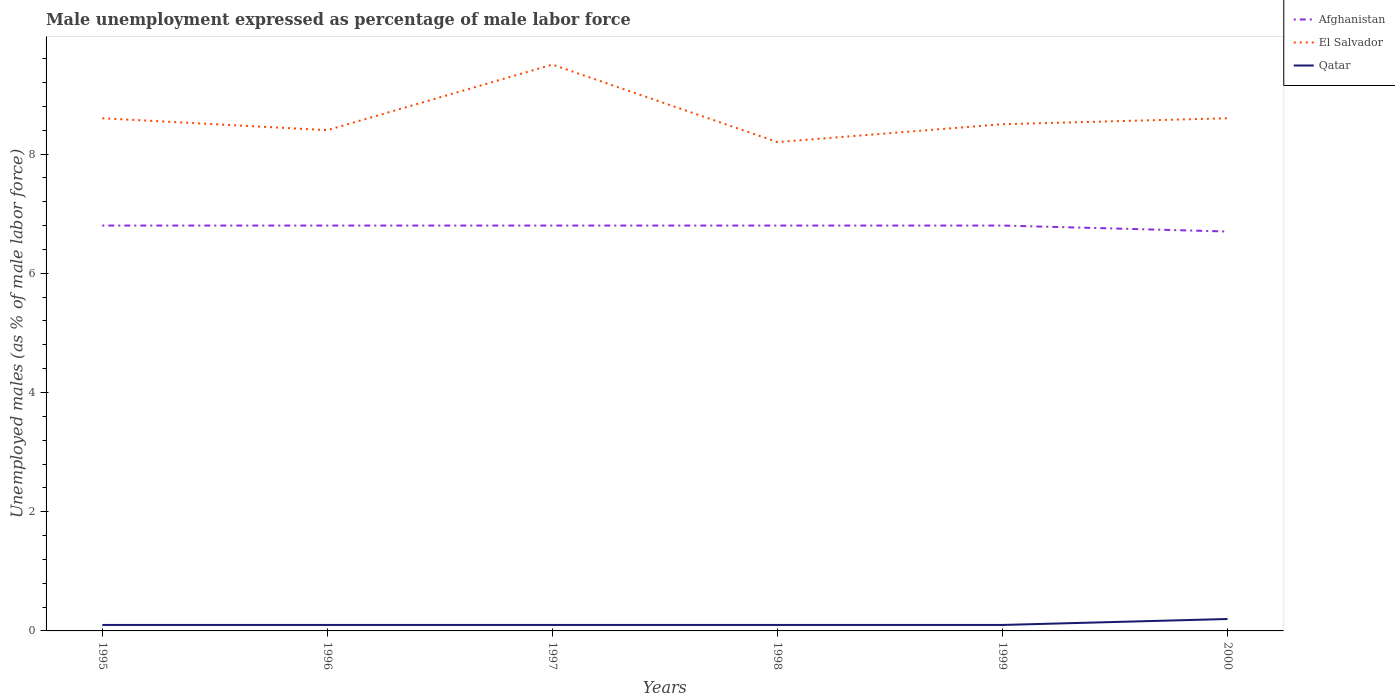How many different coloured lines are there?
Provide a short and direct response. 3. Across all years, what is the maximum unemployment in males in in El Salvador?
Offer a terse response. 8.2. In which year was the unemployment in males in in El Salvador maximum?
Keep it short and to the point. 1998. What is the total unemployment in males in in Qatar in the graph?
Your answer should be compact. -0.1. What is the difference between the highest and the second highest unemployment in males in in Afghanistan?
Your answer should be compact. 0.1. What is the difference between the highest and the lowest unemployment in males in in Qatar?
Your response must be concise. 1. How many lines are there?
Give a very brief answer. 3. Does the graph contain any zero values?
Provide a succinct answer. No. Where does the legend appear in the graph?
Give a very brief answer. Top right. How are the legend labels stacked?
Provide a succinct answer. Vertical. What is the title of the graph?
Ensure brevity in your answer.  Male unemployment expressed as percentage of male labor force. What is the label or title of the X-axis?
Provide a short and direct response. Years. What is the label or title of the Y-axis?
Your response must be concise. Unemployed males (as % of male labor force). What is the Unemployed males (as % of male labor force) of Afghanistan in 1995?
Your answer should be compact. 6.8. What is the Unemployed males (as % of male labor force) in El Salvador in 1995?
Offer a terse response. 8.6. What is the Unemployed males (as % of male labor force) in Qatar in 1995?
Ensure brevity in your answer.  0.1. What is the Unemployed males (as % of male labor force) of Afghanistan in 1996?
Your answer should be compact. 6.8. What is the Unemployed males (as % of male labor force) in El Salvador in 1996?
Offer a very short reply. 8.4. What is the Unemployed males (as % of male labor force) in Qatar in 1996?
Make the answer very short. 0.1. What is the Unemployed males (as % of male labor force) of Afghanistan in 1997?
Provide a succinct answer. 6.8. What is the Unemployed males (as % of male labor force) in Qatar in 1997?
Make the answer very short. 0.1. What is the Unemployed males (as % of male labor force) of Afghanistan in 1998?
Offer a terse response. 6.8. What is the Unemployed males (as % of male labor force) of El Salvador in 1998?
Ensure brevity in your answer.  8.2. What is the Unemployed males (as % of male labor force) of Qatar in 1998?
Your response must be concise. 0.1. What is the Unemployed males (as % of male labor force) in Afghanistan in 1999?
Offer a very short reply. 6.8. What is the Unemployed males (as % of male labor force) in Qatar in 1999?
Provide a succinct answer. 0.1. What is the Unemployed males (as % of male labor force) of Afghanistan in 2000?
Provide a short and direct response. 6.7. What is the Unemployed males (as % of male labor force) of El Salvador in 2000?
Provide a succinct answer. 8.6. What is the Unemployed males (as % of male labor force) of Qatar in 2000?
Your answer should be compact. 0.2. Across all years, what is the maximum Unemployed males (as % of male labor force) in Afghanistan?
Offer a very short reply. 6.8. Across all years, what is the maximum Unemployed males (as % of male labor force) of Qatar?
Ensure brevity in your answer.  0.2. Across all years, what is the minimum Unemployed males (as % of male labor force) in Afghanistan?
Offer a very short reply. 6.7. Across all years, what is the minimum Unemployed males (as % of male labor force) in El Salvador?
Provide a short and direct response. 8.2. Across all years, what is the minimum Unemployed males (as % of male labor force) in Qatar?
Your answer should be compact. 0.1. What is the total Unemployed males (as % of male labor force) of Afghanistan in the graph?
Your answer should be compact. 40.7. What is the total Unemployed males (as % of male labor force) of El Salvador in the graph?
Your answer should be very brief. 51.8. What is the difference between the Unemployed males (as % of male labor force) of Afghanistan in 1995 and that in 1996?
Offer a terse response. 0. What is the difference between the Unemployed males (as % of male labor force) in Qatar in 1995 and that in 1996?
Your response must be concise. 0. What is the difference between the Unemployed males (as % of male labor force) of Afghanistan in 1995 and that in 1997?
Your response must be concise. 0. What is the difference between the Unemployed males (as % of male labor force) in Qatar in 1995 and that in 1997?
Keep it short and to the point. 0. What is the difference between the Unemployed males (as % of male labor force) of Afghanistan in 1995 and that in 1998?
Offer a very short reply. 0. What is the difference between the Unemployed males (as % of male labor force) of Qatar in 1995 and that in 1998?
Give a very brief answer. 0. What is the difference between the Unemployed males (as % of male labor force) of Afghanistan in 1995 and that in 1999?
Offer a terse response. 0. What is the difference between the Unemployed males (as % of male labor force) in El Salvador in 1995 and that in 2000?
Provide a short and direct response. 0. What is the difference between the Unemployed males (as % of male labor force) in Qatar in 1995 and that in 2000?
Keep it short and to the point. -0.1. What is the difference between the Unemployed males (as % of male labor force) in El Salvador in 1996 and that in 1997?
Provide a short and direct response. -1.1. What is the difference between the Unemployed males (as % of male labor force) in Qatar in 1996 and that in 1998?
Your response must be concise. 0. What is the difference between the Unemployed males (as % of male labor force) in Afghanistan in 1996 and that in 1999?
Your answer should be very brief. 0. What is the difference between the Unemployed males (as % of male labor force) of Qatar in 1996 and that in 1999?
Ensure brevity in your answer.  0. What is the difference between the Unemployed males (as % of male labor force) in El Salvador in 1996 and that in 2000?
Offer a very short reply. -0.2. What is the difference between the Unemployed males (as % of male labor force) in Qatar in 1997 and that in 1998?
Ensure brevity in your answer.  0. What is the difference between the Unemployed males (as % of male labor force) of El Salvador in 1997 and that in 1999?
Offer a very short reply. 1. What is the difference between the Unemployed males (as % of male labor force) of Qatar in 1997 and that in 1999?
Keep it short and to the point. 0. What is the difference between the Unemployed males (as % of male labor force) in Afghanistan in 1997 and that in 2000?
Offer a very short reply. 0.1. What is the difference between the Unemployed males (as % of male labor force) of Qatar in 1998 and that in 1999?
Offer a very short reply. 0. What is the difference between the Unemployed males (as % of male labor force) of El Salvador in 1998 and that in 2000?
Offer a terse response. -0.4. What is the difference between the Unemployed males (as % of male labor force) of Qatar in 1998 and that in 2000?
Provide a succinct answer. -0.1. What is the difference between the Unemployed males (as % of male labor force) in Afghanistan in 1999 and that in 2000?
Your response must be concise. 0.1. What is the difference between the Unemployed males (as % of male labor force) in Afghanistan in 1995 and the Unemployed males (as % of male labor force) in El Salvador in 1996?
Keep it short and to the point. -1.6. What is the difference between the Unemployed males (as % of male labor force) in Afghanistan in 1995 and the Unemployed males (as % of male labor force) in Qatar in 1997?
Make the answer very short. 6.7. What is the difference between the Unemployed males (as % of male labor force) of El Salvador in 1995 and the Unemployed males (as % of male labor force) of Qatar in 1997?
Provide a succinct answer. 8.5. What is the difference between the Unemployed males (as % of male labor force) in Afghanistan in 1995 and the Unemployed males (as % of male labor force) in El Salvador in 1998?
Make the answer very short. -1.4. What is the difference between the Unemployed males (as % of male labor force) in Afghanistan in 1995 and the Unemployed males (as % of male labor force) in Qatar in 1999?
Your answer should be very brief. 6.7. What is the difference between the Unemployed males (as % of male labor force) in Afghanistan in 1995 and the Unemployed males (as % of male labor force) in El Salvador in 2000?
Your answer should be compact. -1.8. What is the difference between the Unemployed males (as % of male labor force) of Afghanistan in 1995 and the Unemployed males (as % of male labor force) of Qatar in 2000?
Offer a very short reply. 6.6. What is the difference between the Unemployed males (as % of male labor force) of El Salvador in 1995 and the Unemployed males (as % of male labor force) of Qatar in 2000?
Ensure brevity in your answer.  8.4. What is the difference between the Unemployed males (as % of male labor force) of Afghanistan in 1996 and the Unemployed males (as % of male labor force) of El Salvador in 1997?
Your answer should be compact. -2.7. What is the difference between the Unemployed males (as % of male labor force) of El Salvador in 1996 and the Unemployed males (as % of male labor force) of Qatar in 1997?
Offer a very short reply. 8.3. What is the difference between the Unemployed males (as % of male labor force) in Afghanistan in 1996 and the Unemployed males (as % of male labor force) in El Salvador in 1998?
Provide a succinct answer. -1.4. What is the difference between the Unemployed males (as % of male labor force) in Afghanistan in 1996 and the Unemployed males (as % of male labor force) in Qatar in 1998?
Your answer should be compact. 6.7. What is the difference between the Unemployed males (as % of male labor force) in Afghanistan in 1996 and the Unemployed males (as % of male labor force) in El Salvador in 2000?
Your answer should be compact. -1.8. What is the difference between the Unemployed males (as % of male labor force) in Afghanistan in 1996 and the Unemployed males (as % of male labor force) in Qatar in 2000?
Your answer should be compact. 6.6. What is the difference between the Unemployed males (as % of male labor force) of Afghanistan in 1997 and the Unemployed males (as % of male labor force) of El Salvador in 1998?
Your response must be concise. -1.4. What is the difference between the Unemployed males (as % of male labor force) in Afghanistan in 1997 and the Unemployed males (as % of male labor force) in Qatar in 1998?
Your response must be concise. 6.7. What is the difference between the Unemployed males (as % of male labor force) in El Salvador in 1997 and the Unemployed males (as % of male labor force) in Qatar in 1998?
Ensure brevity in your answer.  9.4. What is the difference between the Unemployed males (as % of male labor force) of Afghanistan in 1997 and the Unemployed males (as % of male labor force) of El Salvador in 1999?
Give a very brief answer. -1.7. What is the difference between the Unemployed males (as % of male labor force) in Afghanistan in 1997 and the Unemployed males (as % of male labor force) in Qatar in 1999?
Your answer should be compact. 6.7. What is the difference between the Unemployed males (as % of male labor force) in El Salvador in 1997 and the Unemployed males (as % of male labor force) in Qatar in 1999?
Ensure brevity in your answer.  9.4. What is the difference between the Unemployed males (as % of male labor force) of Afghanistan in 1997 and the Unemployed males (as % of male labor force) of Qatar in 2000?
Offer a very short reply. 6.6. What is the difference between the Unemployed males (as % of male labor force) in El Salvador in 1997 and the Unemployed males (as % of male labor force) in Qatar in 2000?
Provide a succinct answer. 9.3. What is the difference between the Unemployed males (as % of male labor force) in Afghanistan in 1998 and the Unemployed males (as % of male labor force) in Qatar in 1999?
Your answer should be very brief. 6.7. What is the difference between the Unemployed males (as % of male labor force) of El Salvador in 1998 and the Unemployed males (as % of male labor force) of Qatar in 1999?
Give a very brief answer. 8.1. What is the difference between the Unemployed males (as % of male labor force) in El Salvador in 1999 and the Unemployed males (as % of male labor force) in Qatar in 2000?
Your answer should be very brief. 8.3. What is the average Unemployed males (as % of male labor force) of Afghanistan per year?
Offer a very short reply. 6.78. What is the average Unemployed males (as % of male labor force) of El Salvador per year?
Your answer should be compact. 8.63. What is the average Unemployed males (as % of male labor force) of Qatar per year?
Ensure brevity in your answer.  0.12. In the year 1997, what is the difference between the Unemployed males (as % of male labor force) of Afghanistan and Unemployed males (as % of male labor force) of El Salvador?
Your response must be concise. -2.7. In the year 1999, what is the difference between the Unemployed males (as % of male labor force) in Afghanistan and Unemployed males (as % of male labor force) in El Salvador?
Provide a succinct answer. -1.7. In the year 1999, what is the difference between the Unemployed males (as % of male labor force) in Afghanistan and Unemployed males (as % of male labor force) in Qatar?
Offer a terse response. 6.7. What is the ratio of the Unemployed males (as % of male labor force) of Afghanistan in 1995 to that in 1996?
Provide a succinct answer. 1. What is the ratio of the Unemployed males (as % of male labor force) in El Salvador in 1995 to that in 1996?
Offer a terse response. 1.02. What is the ratio of the Unemployed males (as % of male labor force) in Qatar in 1995 to that in 1996?
Your answer should be compact. 1. What is the ratio of the Unemployed males (as % of male labor force) of El Salvador in 1995 to that in 1997?
Keep it short and to the point. 0.91. What is the ratio of the Unemployed males (as % of male labor force) of El Salvador in 1995 to that in 1998?
Keep it short and to the point. 1.05. What is the ratio of the Unemployed males (as % of male labor force) in Qatar in 1995 to that in 1998?
Make the answer very short. 1. What is the ratio of the Unemployed males (as % of male labor force) of Afghanistan in 1995 to that in 1999?
Keep it short and to the point. 1. What is the ratio of the Unemployed males (as % of male labor force) of El Salvador in 1995 to that in 1999?
Offer a very short reply. 1.01. What is the ratio of the Unemployed males (as % of male labor force) in Qatar in 1995 to that in 1999?
Offer a very short reply. 1. What is the ratio of the Unemployed males (as % of male labor force) of Afghanistan in 1995 to that in 2000?
Your response must be concise. 1.01. What is the ratio of the Unemployed males (as % of male labor force) of Afghanistan in 1996 to that in 1997?
Keep it short and to the point. 1. What is the ratio of the Unemployed males (as % of male labor force) in El Salvador in 1996 to that in 1997?
Give a very brief answer. 0.88. What is the ratio of the Unemployed males (as % of male labor force) of Qatar in 1996 to that in 1997?
Provide a succinct answer. 1. What is the ratio of the Unemployed males (as % of male labor force) of Afghanistan in 1996 to that in 1998?
Ensure brevity in your answer.  1. What is the ratio of the Unemployed males (as % of male labor force) in El Salvador in 1996 to that in 1998?
Keep it short and to the point. 1.02. What is the ratio of the Unemployed males (as % of male labor force) of Qatar in 1996 to that in 1998?
Provide a short and direct response. 1. What is the ratio of the Unemployed males (as % of male labor force) in Afghanistan in 1996 to that in 1999?
Offer a terse response. 1. What is the ratio of the Unemployed males (as % of male labor force) in El Salvador in 1996 to that in 1999?
Provide a succinct answer. 0.99. What is the ratio of the Unemployed males (as % of male labor force) in Qatar in 1996 to that in 1999?
Offer a very short reply. 1. What is the ratio of the Unemployed males (as % of male labor force) of Afghanistan in 1996 to that in 2000?
Provide a succinct answer. 1.01. What is the ratio of the Unemployed males (as % of male labor force) in El Salvador in 1996 to that in 2000?
Ensure brevity in your answer.  0.98. What is the ratio of the Unemployed males (as % of male labor force) in Afghanistan in 1997 to that in 1998?
Give a very brief answer. 1. What is the ratio of the Unemployed males (as % of male labor force) in El Salvador in 1997 to that in 1998?
Your answer should be very brief. 1.16. What is the ratio of the Unemployed males (as % of male labor force) in Afghanistan in 1997 to that in 1999?
Give a very brief answer. 1. What is the ratio of the Unemployed males (as % of male labor force) of El Salvador in 1997 to that in 1999?
Ensure brevity in your answer.  1.12. What is the ratio of the Unemployed males (as % of male labor force) in Afghanistan in 1997 to that in 2000?
Your response must be concise. 1.01. What is the ratio of the Unemployed males (as % of male labor force) of El Salvador in 1997 to that in 2000?
Keep it short and to the point. 1.1. What is the ratio of the Unemployed males (as % of male labor force) in Qatar in 1997 to that in 2000?
Provide a short and direct response. 0.5. What is the ratio of the Unemployed males (as % of male labor force) of El Salvador in 1998 to that in 1999?
Offer a terse response. 0.96. What is the ratio of the Unemployed males (as % of male labor force) in Qatar in 1998 to that in 1999?
Your answer should be very brief. 1. What is the ratio of the Unemployed males (as % of male labor force) of Afghanistan in 1998 to that in 2000?
Provide a short and direct response. 1.01. What is the ratio of the Unemployed males (as % of male labor force) in El Salvador in 1998 to that in 2000?
Your answer should be compact. 0.95. What is the ratio of the Unemployed males (as % of male labor force) of Qatar in 1998 to that in 2000?
Offer a terse response. 0.5. What is the ratio of the Unemployed males (as % of male labor force) in Afghanistan in 1999 to that in 2000?
Give a very brief answer. 1.01. What is the ratio of the Unemployed males (as % of male labor force) in El Salvador in 1999 to that in 2000?
Keep it short and to the point. 0.99. What is the ratio of the Unemployed males (as % of male labor force) in Qatar in 1999 to that in 2000?
Provide a short and direct response. 0.5. What is the difference between the highest and the second highest Unemployed males (as % of male labor force) in El Salvador?
Offer a terse response. 0.9. What is the difference between the highest and the lowest Unemployed males (as % of male labor force) of El Salvador?
Offer a very short reply. 1.3. What is the difference between the highest and the lowest Unemployed males (as % of male labor force) in Qatar?
Provide a short and direct response. 0.1. 